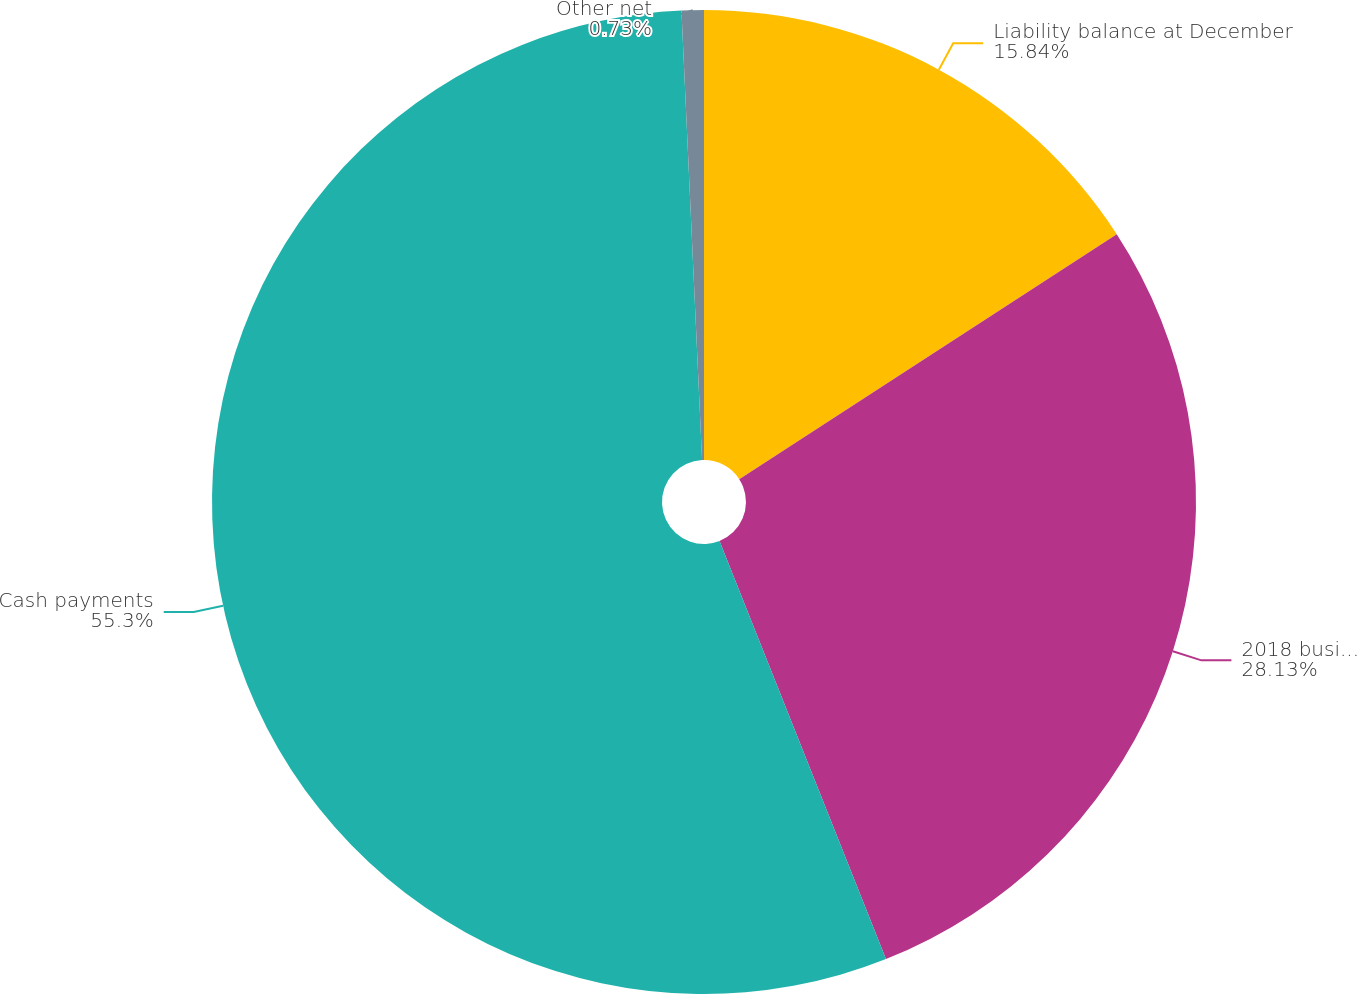Convert chart to OTSL. <chart><loc_0><loc_0><loc_500><loc_500><pie_chart><fcel>Liability balance at December<fcel>2018 business realignment<fcel>Cash payments<fcel>Other net<nl><fcel>15.84%<fcel>28.13%<fcel>55.3%<fcel>0.73%<nl></chart> 